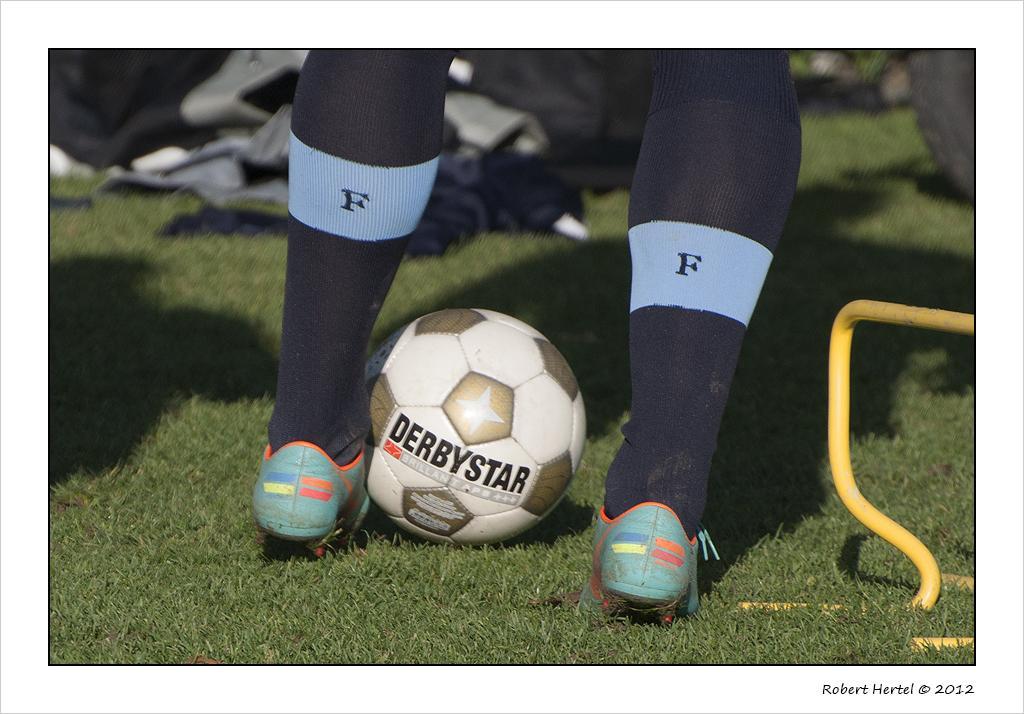In one or two sentences, can you explain what this image depicts? In the image there are two legs of a person and beside the left leg there is a ball on the ground and the background is blurry. 